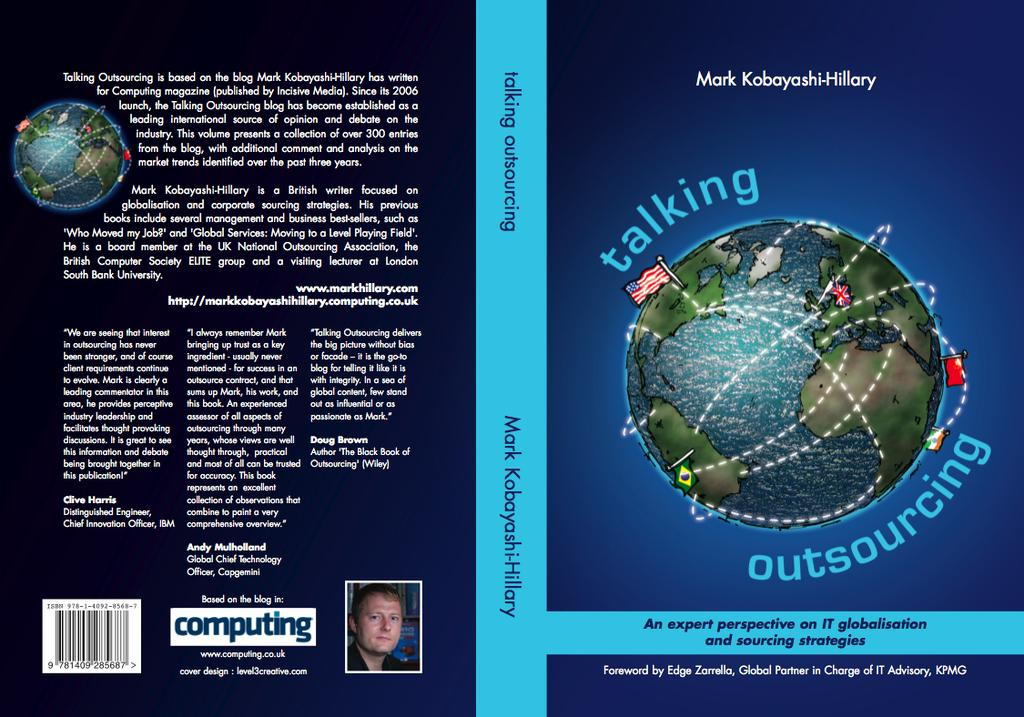What color is the poster in the image? The poster is blue in color. How many bikes are shown in the condition on the poster? There are no bikes or conditions mentioned in the image, as the only fact provided is about the color of the poster. 